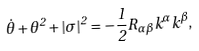<formula> <loc_0><loc_0><loc_500><loc_500>\dot { \theta } + \theta ^ { 2 } + | \sigma | ^ { 2 } = - \frac { 1 } { 2 } R _ { \alpha \beta } k ^ { \alpha } k ^ { \beta } ,</formula> 